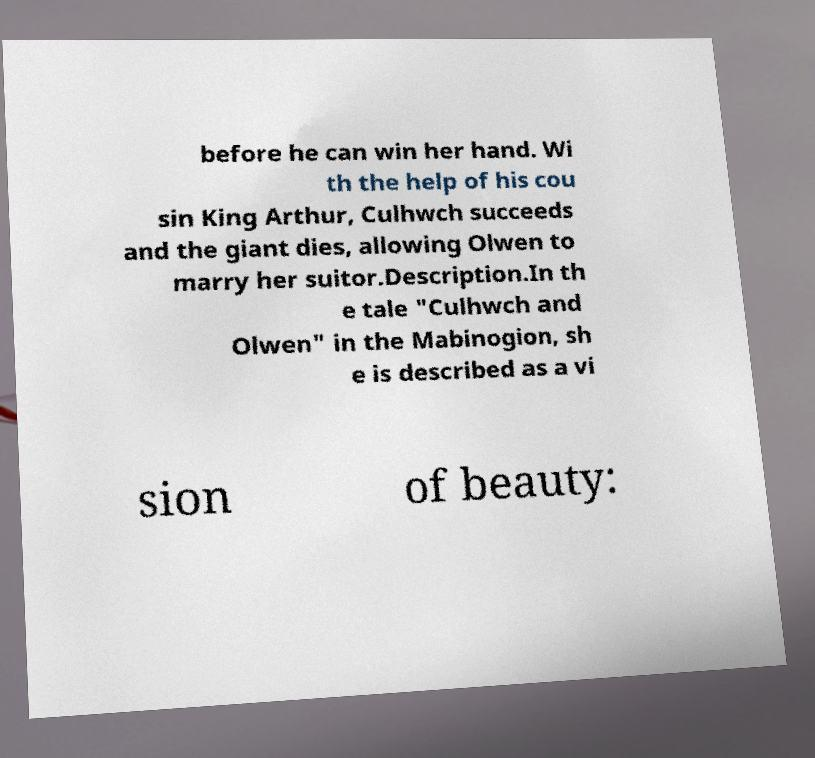I need the written content from this picture converted into text. Can you do that? before he can win her hand. Wi th the help of his cou sin King Arthur, Culhwch succeeds and the giant dies, allowing Olwen to marry her suitor.Description.In th e tale "Culhwch and Olwen" in the Mabinogion, sh e is described as a vi sion of beauty: 